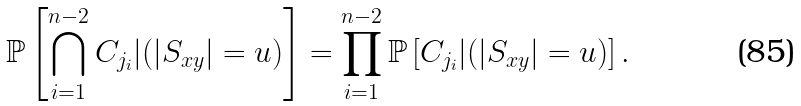<formula> <loc_0><loc_0><loc_500><loc_500>\mathbb { P } \left [ \bigcap _ { i = 1 } ^ { n - 2 } C _ { j _ { i } } | ( | S _ { x y } | = u ) \right ] & = \prod _ { i = 1 } ^ { n - 2 } \mathbb { P } \left [ C _ { j _ { i } } | ( | S _ { x y } | = u ) \right ] .</formula> 